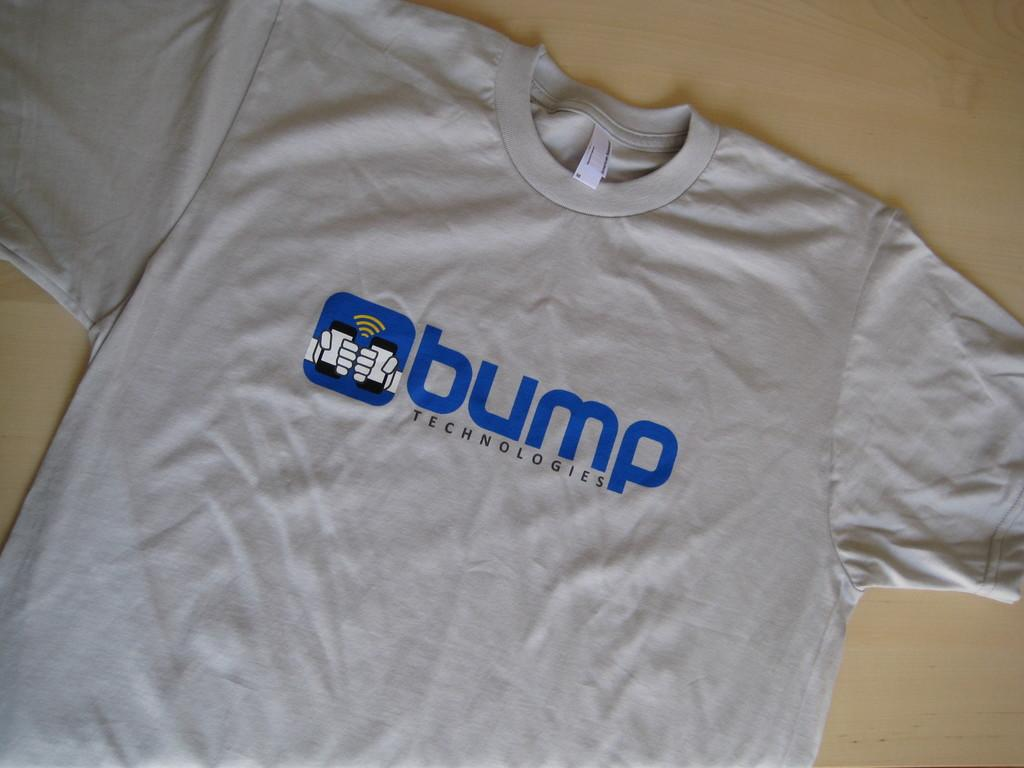<image>
Give a short and clear explanation of the subsequent image. A t-shirt with bump technologies on the front is lying on a table. 